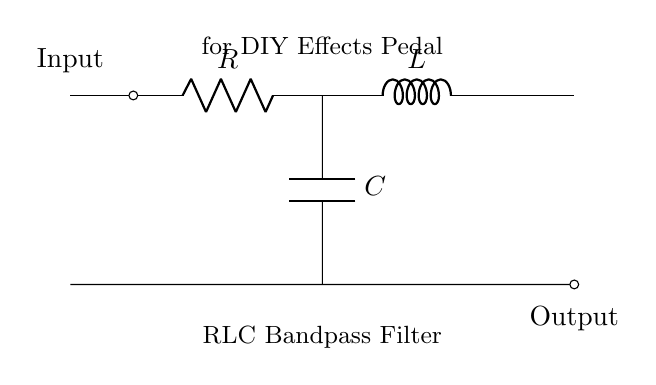What components are present in the circuit? The circuit includes a resistor, an inductor, and a capacitor, which are the three essential components of the RLC circuit. The diagram specifically labels each component.
Answer: Resistor, Inductor, Capacitor What is the purpose of this circuit? The circuit is designed as a bandpass filter, which allows signals within a certain frequency range to pass while attenuating signals outside that range, making it suitable for effects in musical applications.
Answer: Bandpass filter What is connected at the input terminal? The input terminal connects to the circuit at the leftmost point, where you can send signals (audio for the pedal) into the RLC circuit to be processed.
Answer: Signals What type of filter is represented? The filter type depicted in the circuit is a bandpass filter, which is identified by the combination of the resistor, inductor, and capacitor configured to emphasize certain frequency ranges.
Answer: Bandpass How do the components interact in this RLC circuit? The resistor, inductor, and capacitor work together to create a resonant condition that determines the filter's frequency response, where the inductor and capacitor set the resonance frequency while the resistor affects the bandwidth.
Answer: They create resonance What does the 'RLC' denote in the circuit? 'RLC' stands for the combination of the resistor (R), inductor (L), and capacitor (C) in this type of circuit, indicating its integral components and functionality as a filter.
Answer: Resistor, Inductor, Capacitor Where is the output of the circuit taken from? The output is taken from the rightmost terminal at the bottom of the diagram, indicating where the processed sound can be sent to an amplifier or effects output.
Answer: Output terminal 